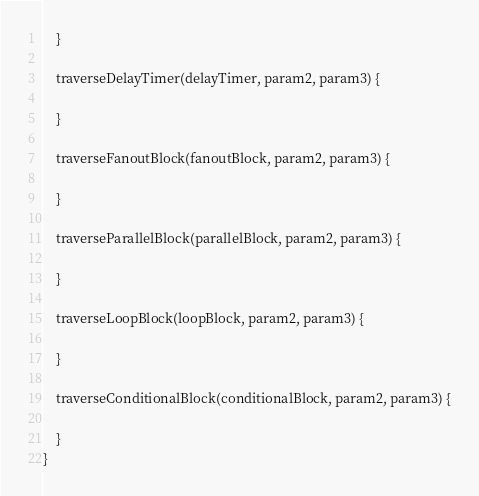Convert code to text. <code><loc_0><loc_0><loc_500><loc_500><_JavaScript_>    }

    traverseDelayTimer(delayTimer, param2, param3) {
        
    }

    traverseFanoutBlock(fanoutBlock, param2, param3) {

    }

    traverseParallelBlock(parallelBlock, param2, param3) {

    }

    traverseLoopBlock(loopBlock, param2, param3) {

    }

    traverseConditionalBlock(conditionalBlock, param2, param3) {

    }
}</code> 